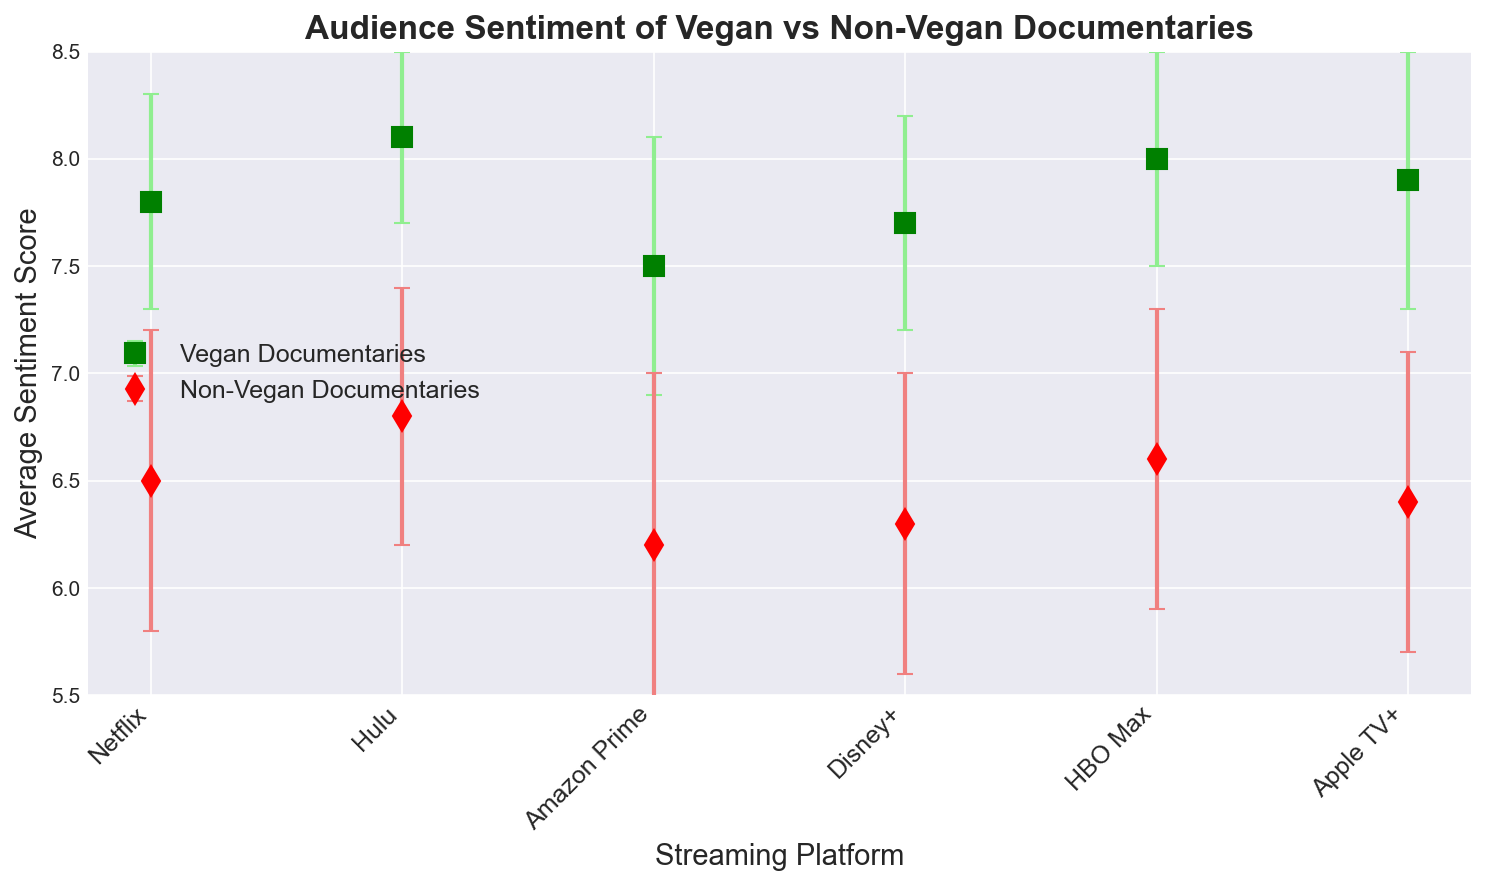What platform has the highest average sentiment for vegan documentaries? We need to check the green markers on the plot and identify which has the highest position on the y-axis. HBO Max shows the highest average sentiment for vegan documentaries.
Answer: HBO Max Which type of documentary generally has higher audience sentiment on Netflix? We need to compare the green and red markers on Netflix. The green marker, representing vegan documentaries, is higher than the red marker for non-vegan documentaries.
Answer: Vegan documentaries What is the difference in average sentiment between vegan and non-vegan documentaries on Amazon Prime? We subtract the average sentiment of non-vegan documentaries (6.2) from the average sentiment of vegan documentaries (7.5) on Amazon Prime. The difference is 7.5 - 6.2 = 1.3.
Answer: 1.3 Is there any platform where the error bars of vegan and non-vegan documentaries overlap? We need to inspect the error bars for each platform. On Hulu, the error bars of vegan documentaries and non-vegan documentaries overlap.
Answer: Hulu Which platform has the lowest average sentiment for non-vegan documentaries? We check the red markers and identify the one with the lowest position on the y-axis. Amazon Prime has the lowest average sentiment for non-vegan documentaries.
Answer: Amazon Prime On which platform is the sentiment for vegan documentaries most consistent, as indicated by the smallest standard deviation? We look for the smallest error bar among the green markers. Hulu has the smallest error bar, indicating the most consistent sentiment.
Answer: Hulu What is the average sentiment across all platforms for vegan documentaries? We sum the average sentiments for vegan documentaries on each platform and divide by the number of platforms: (7.8 + 8.1 + 7.5 + 7.7 + 8.0 + 7.9) / 6 = 47 / 6 = 7.83.
Answer: 7.83 Which documentary type has a larger sentiment standard deviation generally, vegan or non-vegan? We need to compare the sizes of the error bars for green (vegan) and red (non-vegan) markers. Generally, the red error bars appear larger, indicating non-vegan documentaries have a larger sentiment standard deviation.
Answer: Non-vegan Between Netflix and Disney+, which platform shows a higher sentiment for non-vegan documentaries? We need to compare the red markers for Netflix and Disney+. Netflix has a slightly higher position than Disney+, indicating a higher sentiment.
Answer: Netflix 